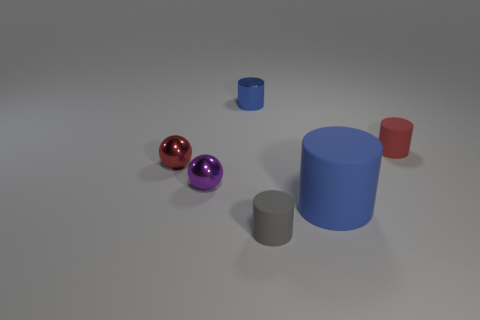Subtract all tiny gray matte cylinders. How many cylinders are left? 3 Add 2 tiny purple spheres. How many objects exist? 8 Subtract all red balls. How many balls are left? 1 Subtract all cylinders. How many objects are left? 2 Subtract 3 cylinders. How many cylinders are left? 1 Subtract all red balls. How many cyan cylinders are left? 0 Subtract all large red metal spheres. Subtract all tiny things. How many objects are left? 1 Add 6 tiny gray cylinders. How many tiny gray cylinders are left? 7 Add 1 big matte cylinders. How many big matte cylinders exist? 2 Subtract 0 yellow spheres. How many objects are left? 6 